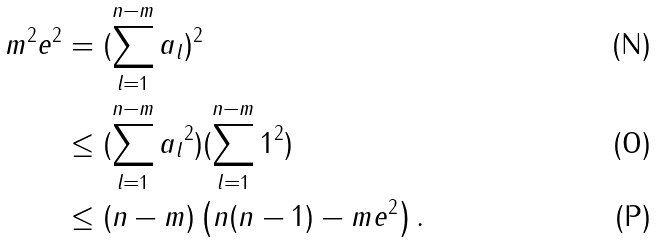Convert formula to latex. <formula><loc_0><loc_0><loc_500><loc_500>m ^ { 2 } e ^ { 2 } & = ( \sum _ { l = 1 } ^ { n - m } a _ { l } ) ^ { 2 } \\ & \leq ( \sum _ { l = 1 } ^ { n - m } { a _ { l } } ^ { 2 } ) ( \sum _ { l = 1 } ^ { n - m } 1 ^ { 2 } ) \\ & \leq ( n - m ) \left ( n ( n - 1 ) - m e ^ { 2 } \right ) .</formula> 